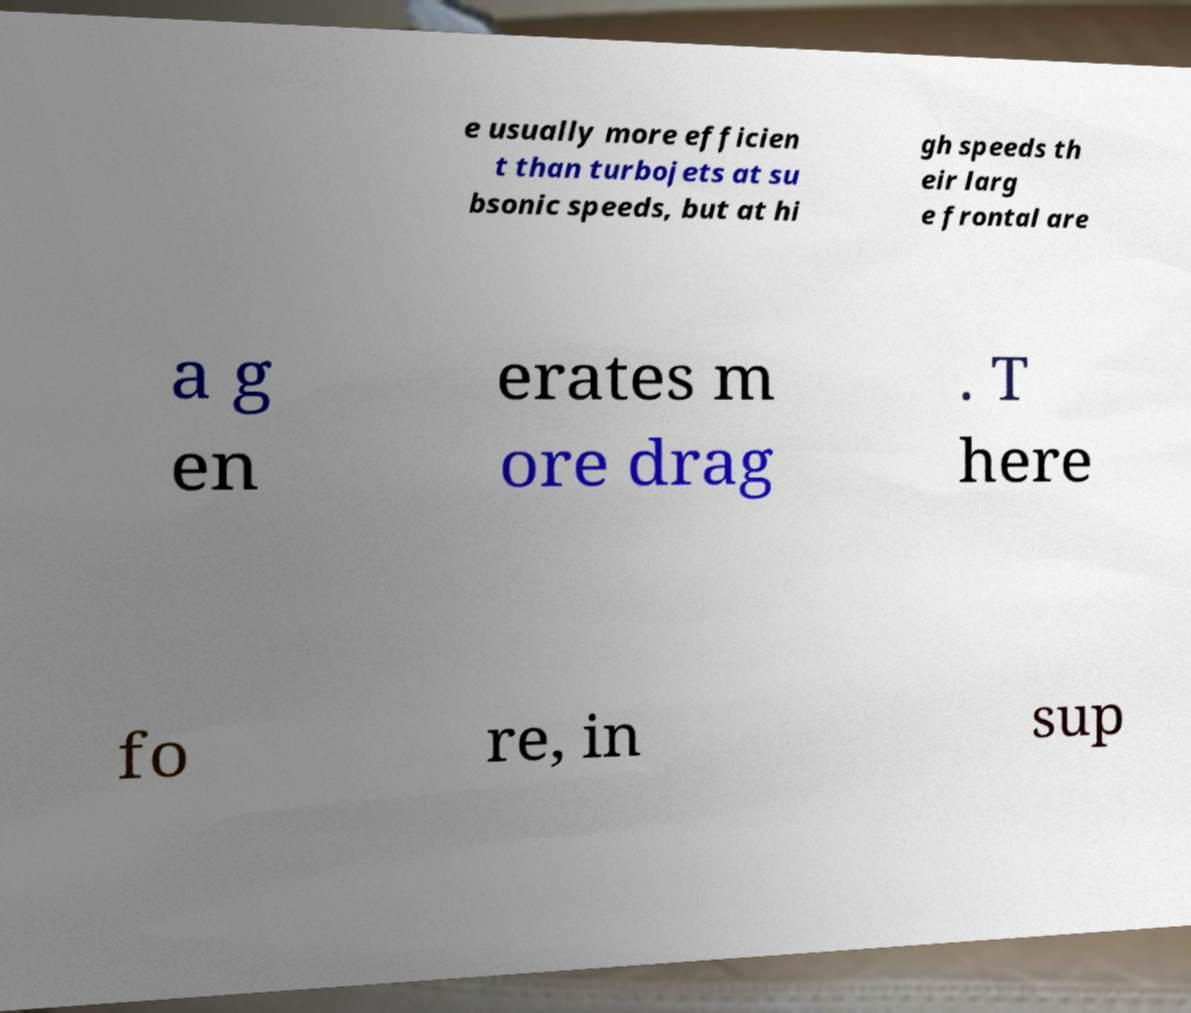Can you accurately transcribe the text from the provided image for me? e usually more efficien t than turbojets at su bsonic speeds, but at hi gh speeds th eir larg e frontal are a g en erates m ore drag . T here fo re, in sup 